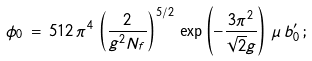<formula> <loc_0><loc_0><loc_500><loc_500>\phi _ { 0 } \, = \, 5 1 2 \, \pi ^ { 4 } \, \left ( \frac { 2 } { g ^ { 2 } N _ { f } } \right ) ^ { 5 / 2 } \, \exp \left ( - \frac { 3 \pi ^ { 2 } } { \sqrt { 2 } g } \right ) \, \mu \, b _ { 0 } ^ { \prime } \, ;</formula> 